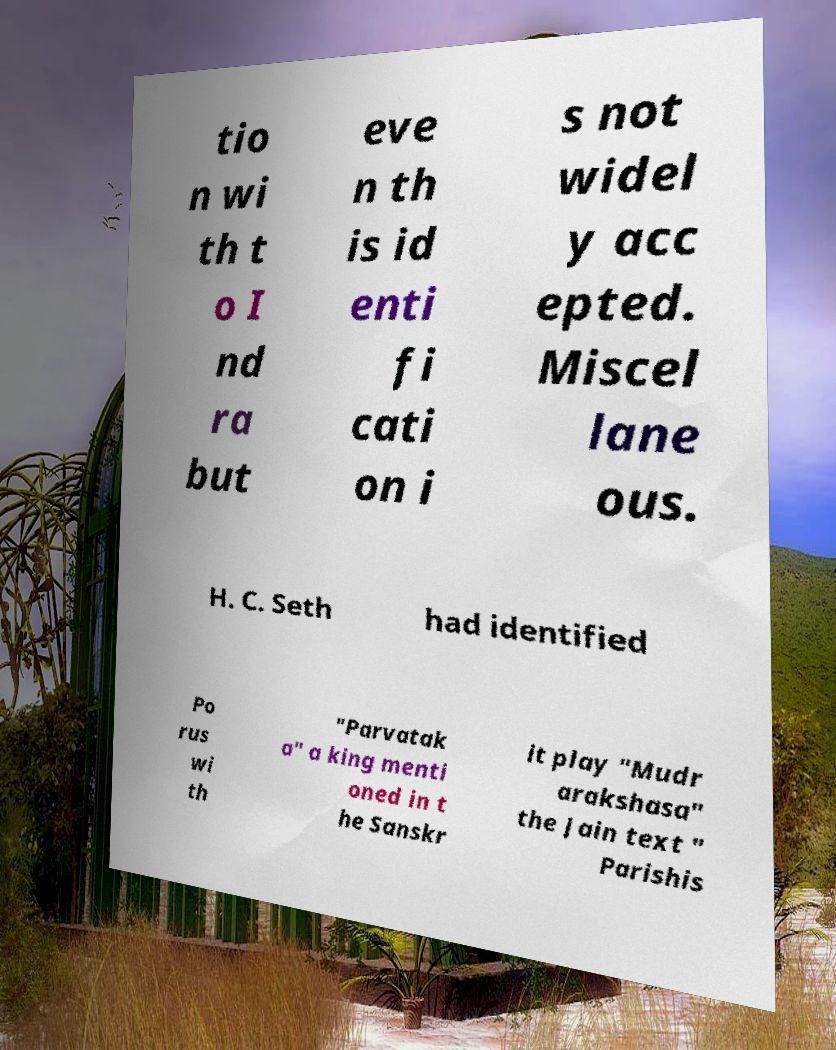For documentation purposes, I need the text within this image transcribed. Could you provide that? tio n wi th t o I nd ra but eve n th is id enti fi cati on i s not widel y acc epted. Miscel lane ous. H. C. Seth had identified Po rus wi th "Parvatak a" a king menti oned in t he Sanskr it play "Mudr arakshasa" the Jain text " Parishis 